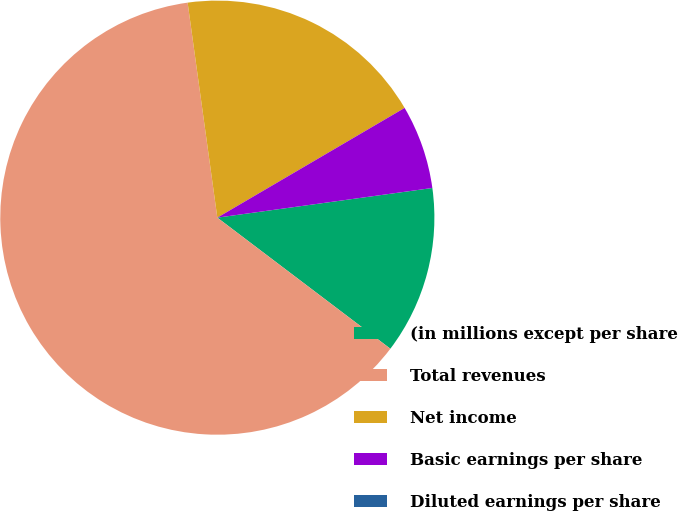Convert chart. <chart><loc_0><loc_0><loc_500><loc_500><pie_chart><fcel>(in millions except per share<fcel>Total revenues<fcel>Net income<fcel>Basic earnings per share<fcel>Diluted earnings per share<nl><fcel>12.5%<fcel>62.49%<fcel>18.75%<fcel>6.25%<fcel>0.0%<nl></chart> 